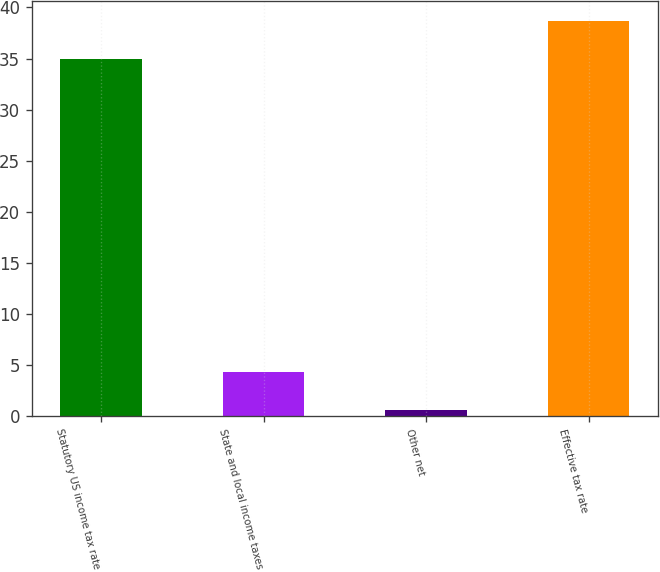Convert chart to OTSL. <chart><loc_0><loc_0><loc_500><loc_500><bar_chart><fcel>Statutory US income tax rate<fcel>State and local income taxes<fcel>Other net<fcel>Effective tax rate<nl><fcel>35<fcel>4.31<fcel>0.6<fcel>38.71<nl></chart> 